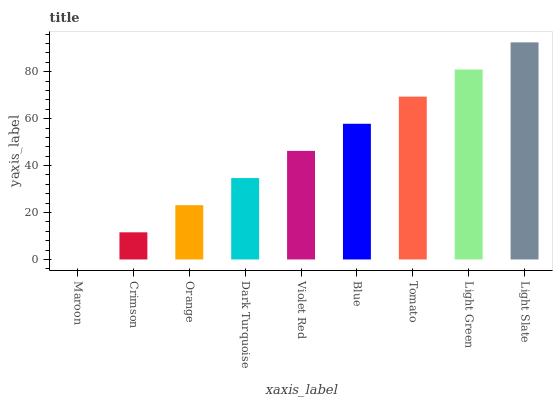Is Maroon the minimum?
Answer yes or no. Yes. Is Light Slate the maximum?
Answer yes or no. Yes. Is Crimson the minimum?
Answer yes or no. No. Is Crimson the maximum?
Answer yes or no. No. Is Crimson greater than Maroon?
Answer yes or no. Yes. Is Maroon less than Crimson?
Answer yes or no. Yes. Is Maroon greater than Crimson?
Answer yes or no. No. Is Crimson less than Maroon?
Answer yes or no. No. Is Violet Red the high median?
Answer yes or no. Yes. Is Violet Red the low median?
Answer yes or no. Yes. Is Maroon the high median?
Answer yes or no. No. Is Maroon the low median?
Answer yes or no. No. 